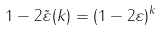<formula> <loc_0><loc_0><loc_500><loc_500>1 - 2 \tilde { \varepsilon } ( k ) = ( 1 - 2 \varepsilon ) ^ { k }</formula> 